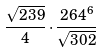Convert formula to latex. <formula><loc_0><loc_0><loc_500><loc_500>\frac { \sqrt { 2 3 9 } } { 4 } \cdot \frac { 2 6 4 ^ { 6 } } { \sqrt { 3 0 2 } }</formula> 